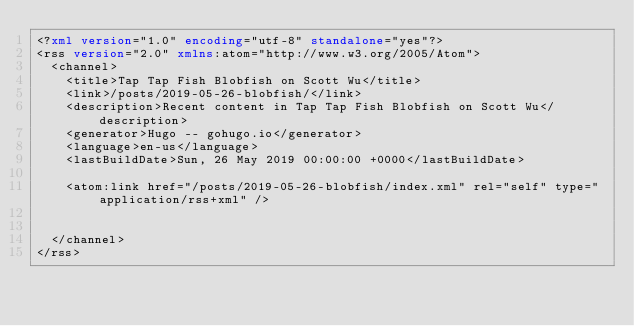Convert code to text. <code><loc_0><loc_0><loc_500><loc_500><_XML_><?xml version="1.0" encoding="utf-8" standalone="yes"?>
<rss version="2.0" xmlns:atom="http://www.w3.org/2005/Atom">
  <channel>
    <title>Tap Tap Fish Blobfish on Scott Wu</title>
    <link>/posts/2019-05-26-blobfish/</link>
    <description>Recent content in Tap Tap Fish Blobfish on Scott Wu</description>
    <generator>Hugo -- gohugo.io</generator>
    <language>en-us</language>
    <lastBuildDate>Sun, 26 May 2019 00:00:00 +0000</lastBuildDate>
    
	<atom:link href="/posts/2019-05-26-blobfish/index.xml" rel="self" type="application/rss+xml" />
    
    
  </channel>
</rss></code> 